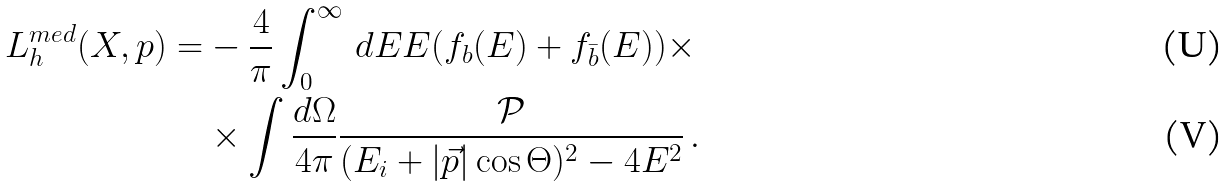Convert formula to latex. <formula><loc_0><loc_0><loc_500><loc_500>L _ { h } ^ { m e d } ( X , p ) = & - \frac { 4 } { \pi } \int _ { 0 } ^ { \infty } \, d E E ( f _ { b } ( E ) + f _ { \bar { b } } ( E ) ) \times \\ & \times \int \frac { d \Omega } { 4 \pi } \frac { \mathcal { P } } { ( E _ { i } + | \vec { p } | \cos \Theta ) ^ { 2 } - 4 E ^ { 2 } } \, .</formula> 